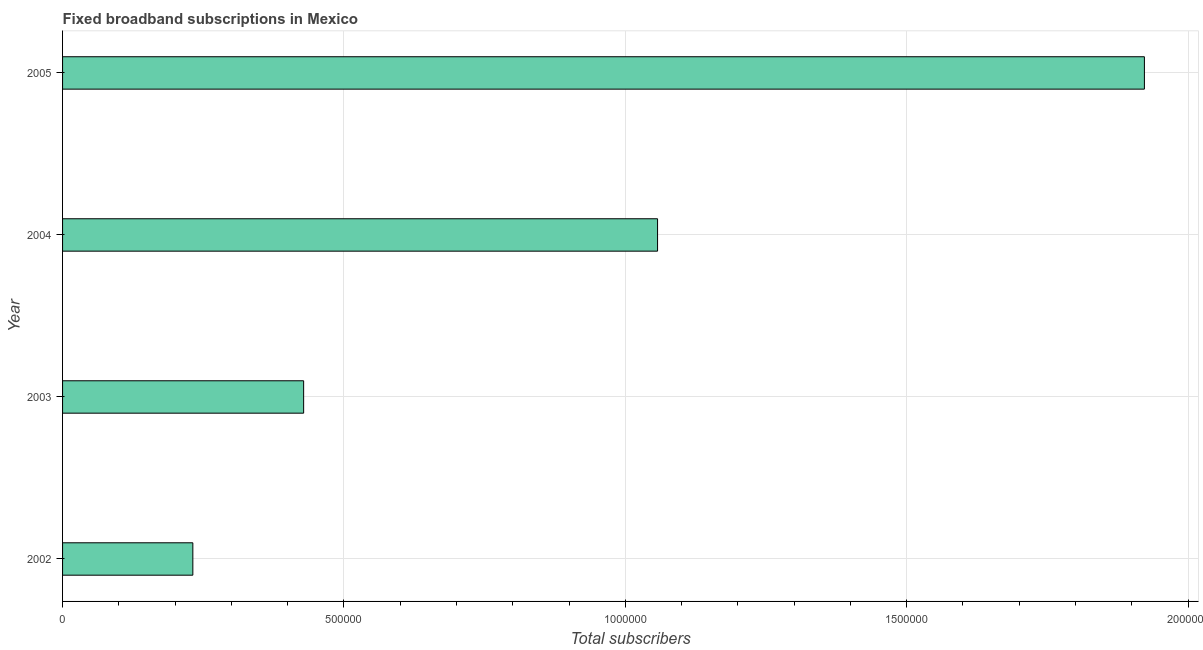Does the graph contain grids?
Your response must be concise. Yes. What is the title of the graph?
Provide a short and direct response. Fixed broadband subscriptions in Mexico. What is the label or title of the X-axis?
Give a very brief answer. Total subscribers. What is the total number of fixed broadband subscriptions in 2004?
Ensure brevity in your answer.  1.06e+06. Across all years, what is the maximum total number of fixed broadband subscriptions?
Provide a short and direct response. 1.92e+06. Across all years, what is the minimum total number of fixed broadband subscriptions?
Make the answer very short. 2.31e+05. In which year was the total number of fixed broadband subscriptions maximum?
Ensure brevity in your answer.  2005. What is the sum of the total number of fixed broadband subscriptions?
Make the answer very short. 3.64e+06. What is the difference between the total number of fixed broadband subscriptions in 2004 and 2005?
Offer a terse response. -8.65e+05. What is the average total number of fixed broadband subscriptions per year?
Make the answer very short. 9.10e+05. What is the median total number of fixed broadband subscriptions?
Offer a very short reply. 7.43e+05. Do a majority of the years between 2002 and 2004 (inclusive) have total number of fixed broadband subscriptions greater than 300000 ?
Make the answer very short. Yes. What is the ratio of the total number of fixed broadband subscriptions in 2003 to that in 2005?
Ensure brevity in your answer.  0.22. Is the total number of fixed broadband subscriptions in 2002 less than that in 2005?
Make the answer very short. Yes. Is the difference between the total number of fixed broadband subscriptions in 2003 and 2005 greater than the difference between any two years?
Offer a terse response. No. What is the difference between the highest and the second highest total number of fixed broadband subscriptions?
Provide a short and direct response. 8.65e+05. Is the sum of the total number of fixed broadband subscriptions in 2002 and 2003 greater than the maximum total number of fixed broadband subscriptions across all years?
Your response must be concise. No. What is the difference between the highest and the lowest total number of fixed broadband subscriptions?
Make the answer very short. 1.69e+06. How many bars are there?
Provide a short and direct response. 4. Are all the bars in the graph horizontal?
Offer a very short reply. Yes. What is the difference between two consecutive major ticks on the X-axis?
Offer a terse response. 5.00e+05. Are the values on the major ticks of X-axis written in scientific E-notation?
Provide a succinct answer. No. What is the Total subscribers in 2002?
Offer a terse response. 2.31e+05. What is the Total subscribers in 2003?
Provide a short and direct response. 4.28e+05. What is the Total subscribers in 2004?
Offer a terse response. 1.06e+06. What is the Total subscribers of 2005?
Your answer should be compact. 1.92e+06. What is the difference between the Total subscribers in 2002 and 2003?
Make the answer very short. -1.97e+05. What is the difference between the Total subscribers in 2002 and 2004?
Your answer should be very brief. -8.26e+05. What is the difference between the Total subscribers in 2002 and 2005?
Offer a terse response. -1.69e+06. What is the difference between the Total subscribers in 2003 and 2004?
Provide a succinct answer. -6.29e+05. What is the difference between the Total subscribers in 2003 and 2005?
Offer a terse response. -1.49e+06. What is the difference between the Total subscribers in 2004 and 2005?
Keep it short and to the point. -8.65e+05. What is the ratio of the Total subscribers in 2002 to that in 2003?
Your answer should be compact. 0.54. What is the ratio of the Total subscribers in 2002 to that in 2004?
Ensure brevity in your answer.  0.22. What is the ratio of the Total subscribers in 2002 to that in 2005?
Give a very brief answer. 0.12. What is the ratio of the Total subscribers in 2003 to that in 2004?
Give a very brief answer. 0.41. What is the ratio of the Total subscribers in 2003 to that in 2005?
Provide a short and direct response. 0.22. What is the ratio of the Total subscribers in 2004 to that in 2005?
Make the answer very short. 0.55. 